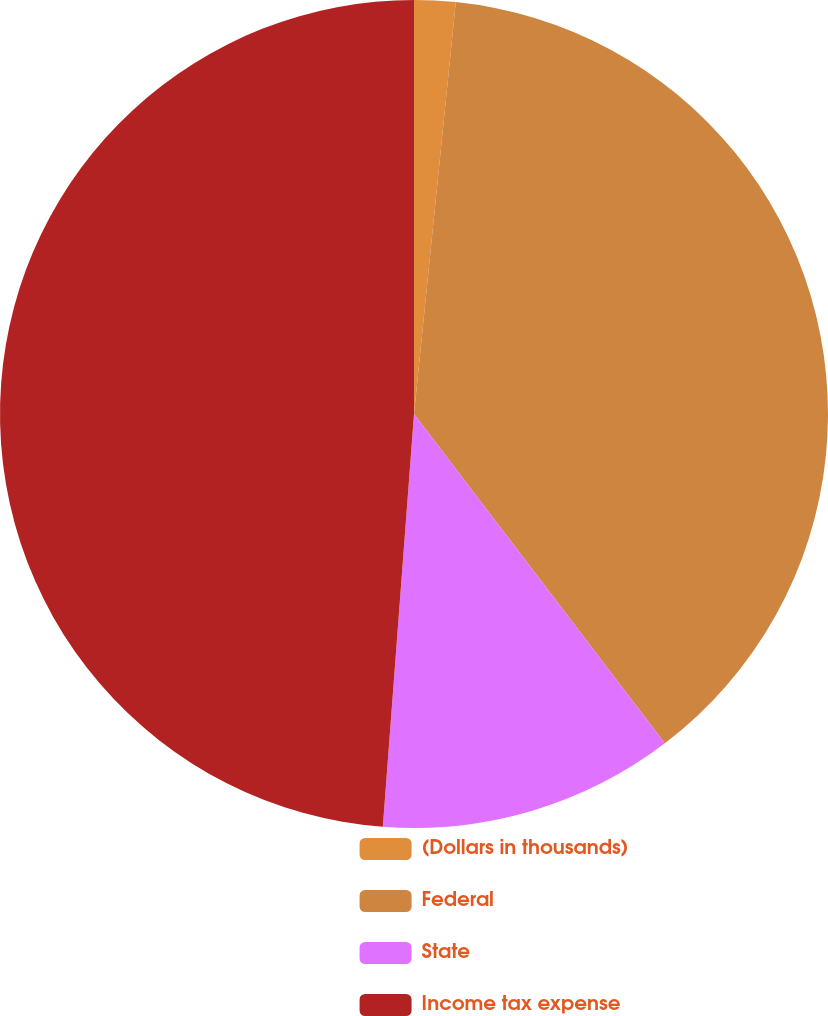<chart> <loc_0><loc_0><loc_500><loc_500><pie_chart><fcel>(Dollars in thousands)<fcel>Federal<fcel>State<fcel>Income tax expense<nl><fcel>1.61%<fcel>38.03%<fcel>11.56%<fcel>48.8%<nl></chart> 